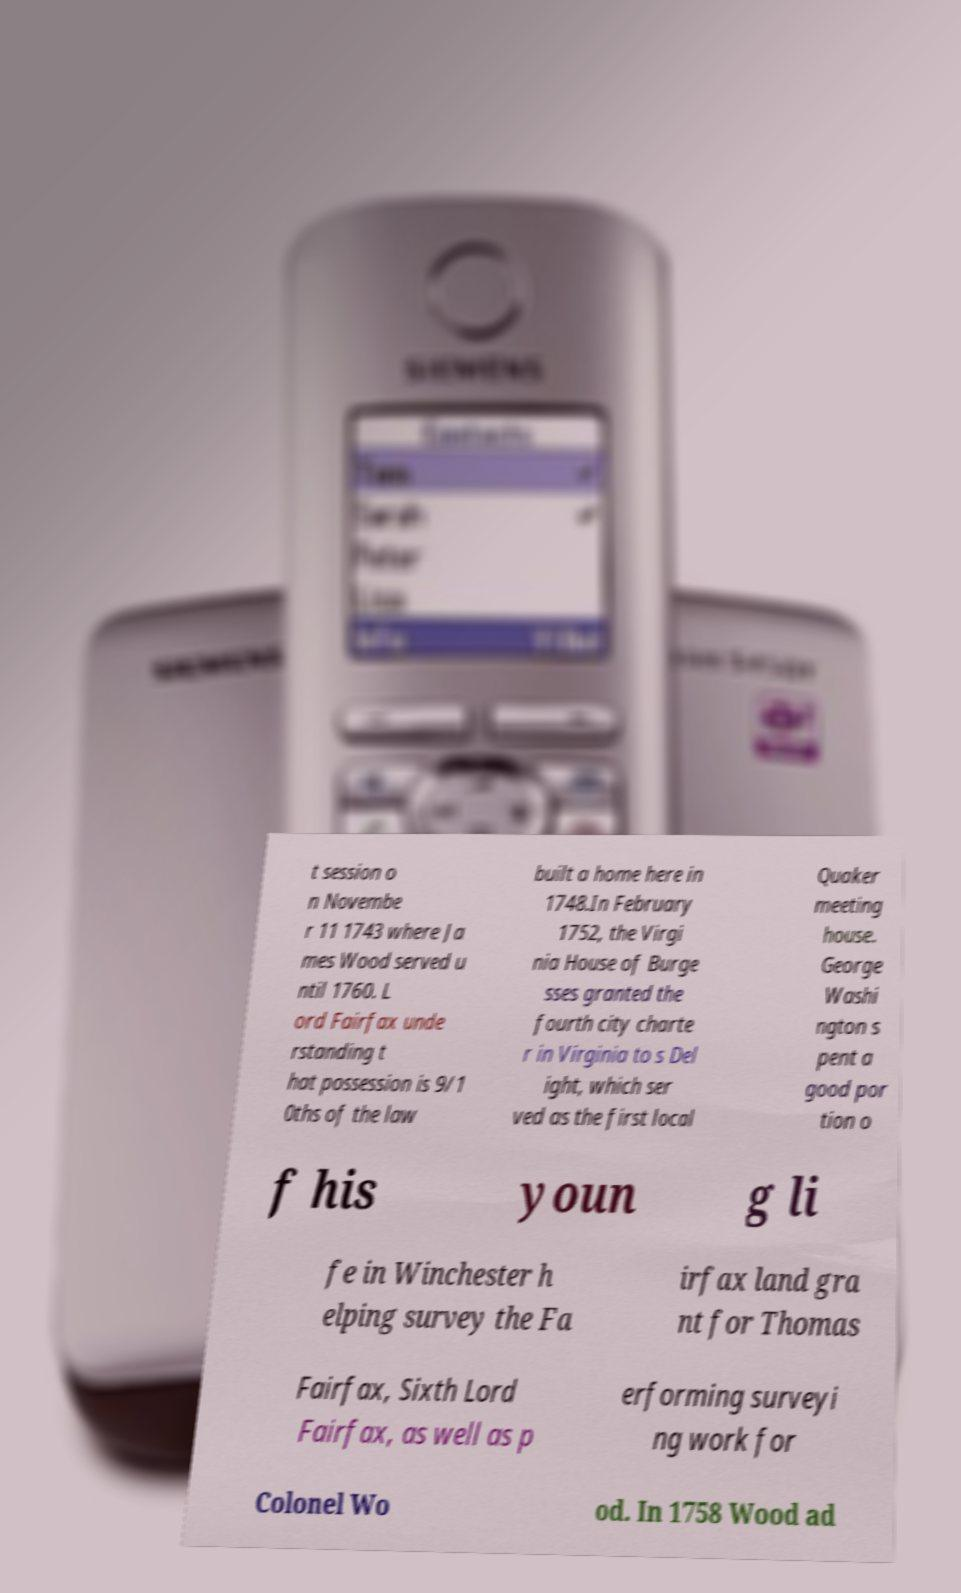What messages or text are displayed in this image? I need them in a readable, typed format. t session o n Novembe r 11 1743 where Ja mes Wood served u ntil 1760. L ord Fairfax unde rstanding t hat possession is 9/1 0ths of the law built a home here in 1748.In February 1752, the Virgi nia House of Burge sses granted the fourth city charte r in Virginia to s Del ight, which ser ved as the first local Quaker meeting house. George Washi ngton s pent a good por tion o f his youn g li fe in Winchester h elping survey the Fa irfax land gra nt for Thomas Fairfax, Sixth Lord Fairfax, as well as p erforming surveyi ng work for Colonel Wo od. In 1758 Wood ad 